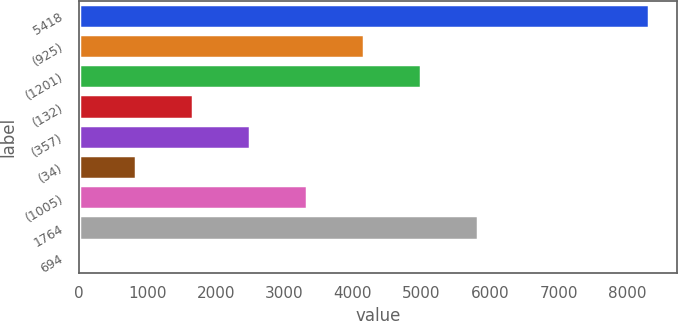Convert chart. <chart><loc_0><loc_0><loc_500><loc_500><bar_chart><fcel>5418<fcel>(925)<fcel>(1201)<fcel>(132)<fcel>(357)<fcel>(34)<fcel>(1005)<fcel>1764<fcel>694<nl><fcel>8315<fcel>4161.63<fcel>4992.3<fcel>1669.62<fcel>2500.29<fcel>838.95<fcel>3330.96<fcel>5822.97<fcel>8.28<nl></chart> 